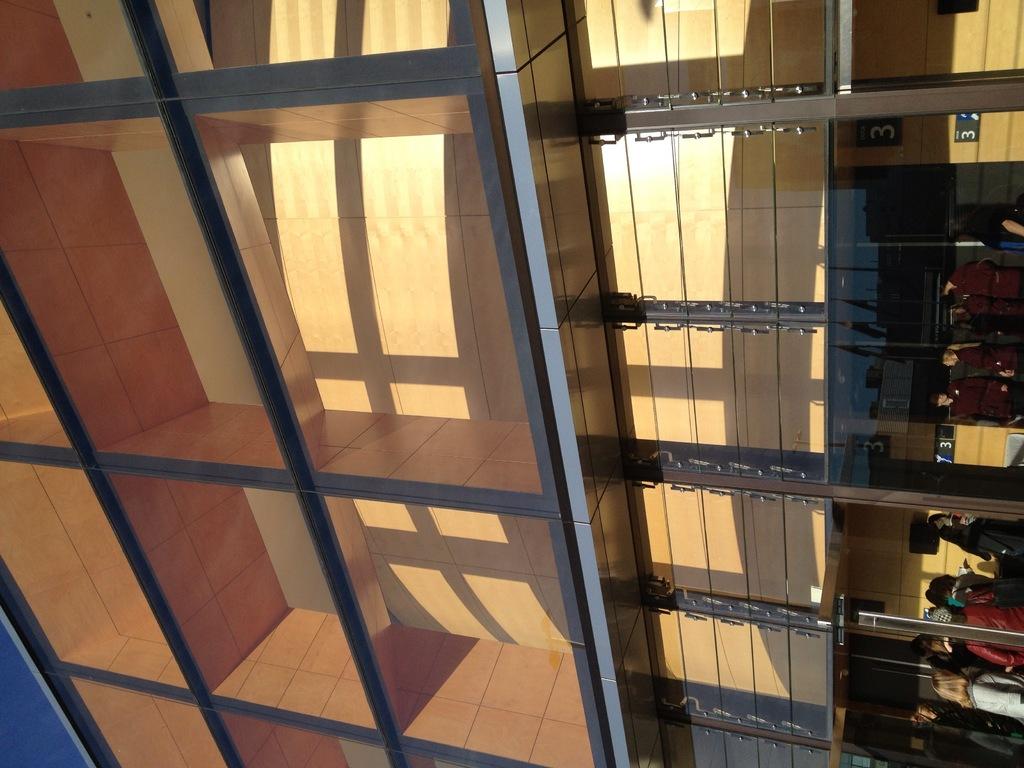What is the number on the top right corner?
Give a very brief answer. 3. 